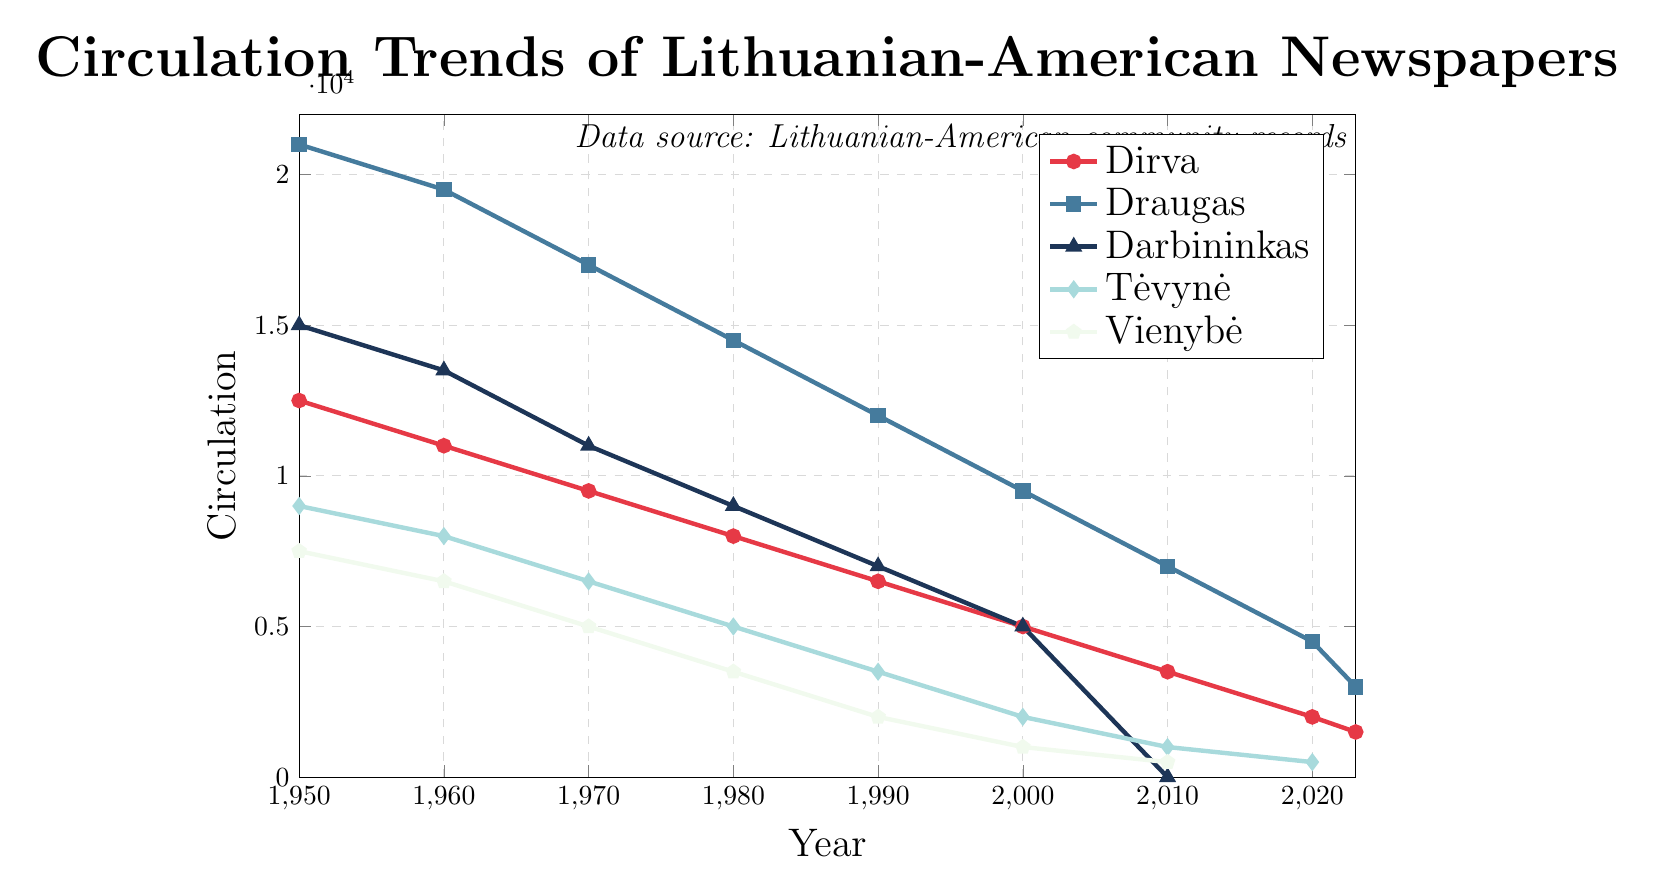Which newspaper had the highest circulation in 1950? By looking at the figure at the year 1950 for all newspapers, Draugas has the highest circulation.
Answer: Draugas What is the exact circulation of Dirva in 2023? Refer to the point on the Dirva line at 2023, which corresponds to a circulation of 1500.
Answer: 1500 Compare the circulation of Darbininkas in 1980 to its circulation in 1970. Which year had the higher circulation? In 1970, Darbininkas had a circulation of 11000, and in 1980, it had a circulation of 9000. 1970's circulation is higher.
Answer: 1970 What is the combined circulation of Tėvynė and Vienybė in 1990? Tėvynė had a circulation of 3500, and Vienybė had 2000. Adding these gives 3500 + 2000 = 5500.
Answer: 5500 Which newspapers transitioned to an "Online only" format by 2020? The figure shows online transitions starting from 2010. By 2020, both Vienybė and Tėvynė transitioned to "Online only."
Answer: Vienybė and Tėvynė How did the circulation of Draugas change from 1950 to 2023? In 1950, Draugas had a circulation of 21000. By 2023, this decreased to 3000.
Answer: Decreased What is the average circulation of Dirva from 1950 to 2023? The circulation values for Dirva are 12500, 11000, 9500, 8000, 6500, 5000, 3500, 2000, and 1500. Summing these gives 59500. Dividing by 9 (number of data points) gives an average of 6611.11.
Answer: 6611.11 Which year marked the largest decrease in Dirva's circulation? By comparing drops year to year, the largest decrease is between 1990 (6500) and 2000 (5000), which is a difference of 1500.
Answer: Between 1990 and 2000 What was the circulation trend of Darbininkas from 1950 to 2010? The trend shows a consistent drop each decade: 15000 in 1950, 13500 in 1960, 11000 in 1970, 9000 in 1980, 7000 in 1990, 5000 in 2000, and 0 (discontinued) in 2010.
Answer: Decreasing By how much did the circulation of Draugas decrease between 1980 and 1990? In 1980, Draugas had a circulation of 14500 and in 1990, it was 12000, a decrease of 2500.
Answer: 2500 